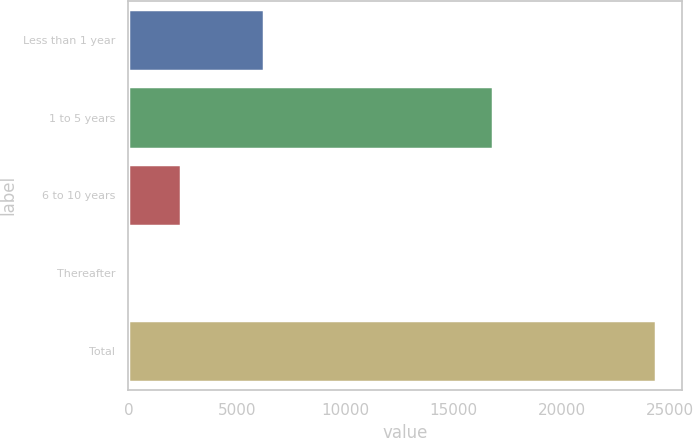Convert chart. <chart><loc_0><loc_0><loc_500><loc_500><bar_chart><fcel>Less than 1 year<fcel>1 to 5 years<fcel>6 to 10 years<fcel>Thereafter<fcel>Total<nl><fcel>6241<fcel>16824<fcel>2437.45<fcel>1.61<fcel>24360<nl></chart> 